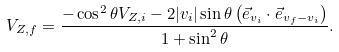Convert formula to latex. <formula><loc_0><loc_0><loc_500><loc_500>V _ { Z , f } = \frac { - \cos ^ { 2 } { \theta } V _ { Z , i } - 2 | v _ { i } | \sin { \theta } \left ( \vec { e } _ { v _ { i } } \cdot \vec { e } _ { v _ { f } - v _ { i } } \right ) } { 1 + \sin ^ { 2 } { \theta } } .</formula> 